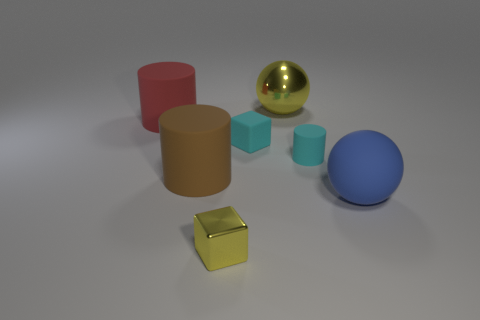Add 1 large green cylinders. How many objects exist? 8 Subtract all cubes. How many objects are left? 5 Add 6 large matte cylinders. How many large matte cylinders exist? 8 Subtract 1 blue balls. How many objects are left? 6 Subtract all big blue shiny cylinders. Subtract all rubber cubes. How many objects are left? 6 Add 1 large red rubber cylinders. How many large red rubber cylinders are left? 2 